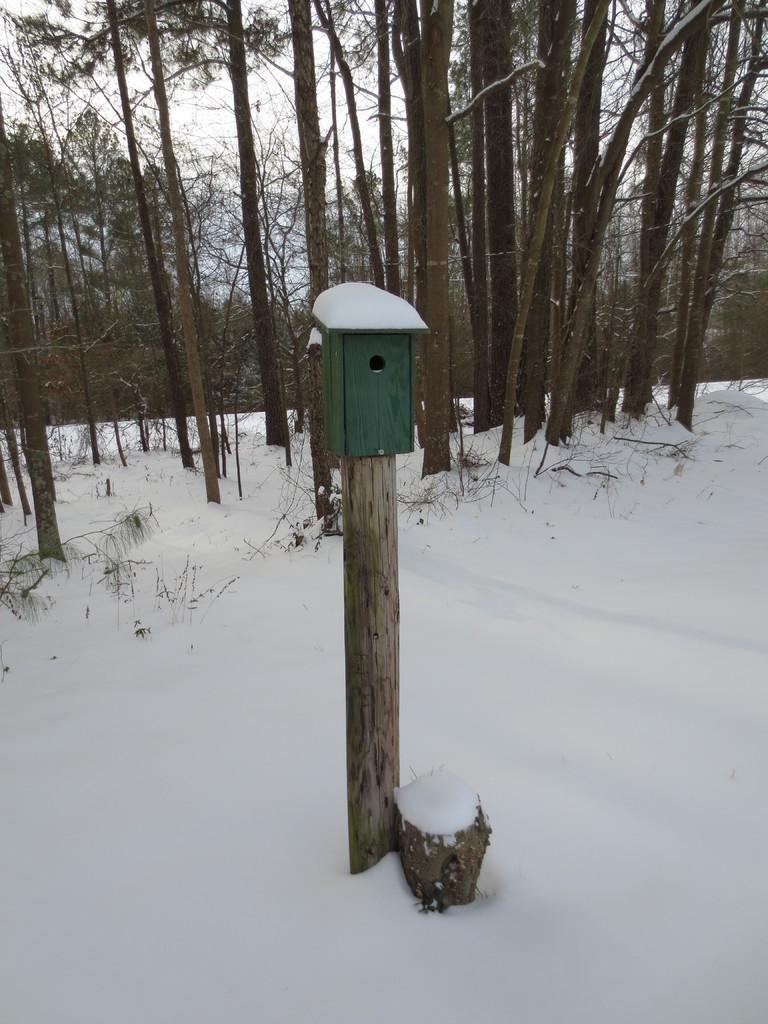What is located in the foreground of the image? There is a pole in the foreground of the image. What can be seen in the background of the image? There are trees in the background of the image. What is visible at the top of the image? The sky is visible at the top of the image. What is the ground covered with in the image? Snow is present at the bottom of the image. How many arms are visible on the worm in the image? There is no worm present in the image, and therefore no arms can be observed. 